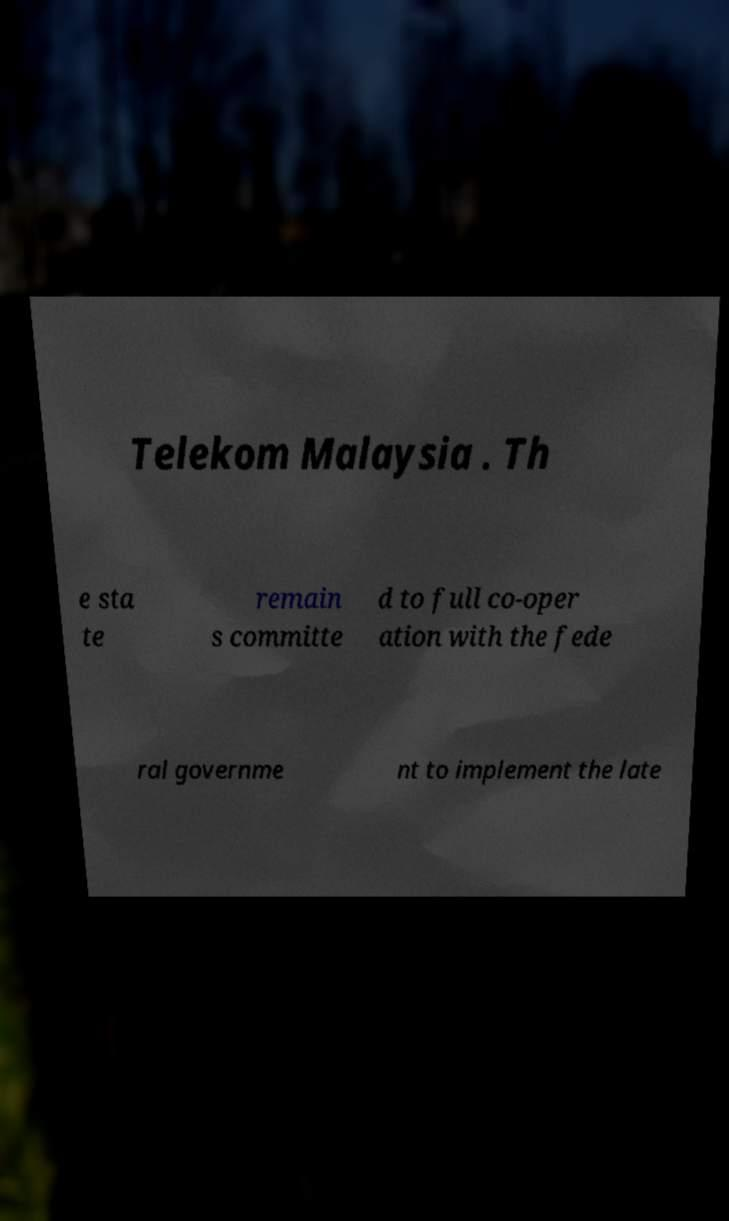Please read and relay the text visible in this image. What does it say? Telekom Malaysia . Th e sta te remain s committe d to full co-oper ation with the fede ral governme nt to implement the late 